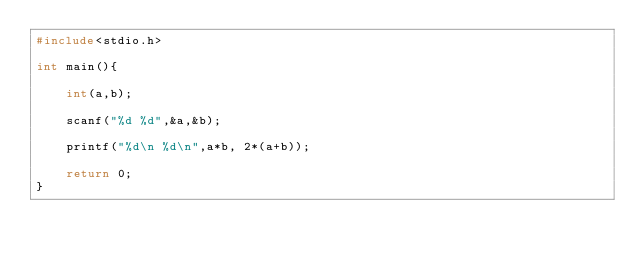<code> <loc_0><loc_0><loc_500><loc_500><_C_>#include<stdio.h>

int main(){

	int(a,b);

	scanf("%d %d",&a,&b);

	printf("%d\n %d\n",a*b, 2*(a+b));

	return 0;
}

</code> 